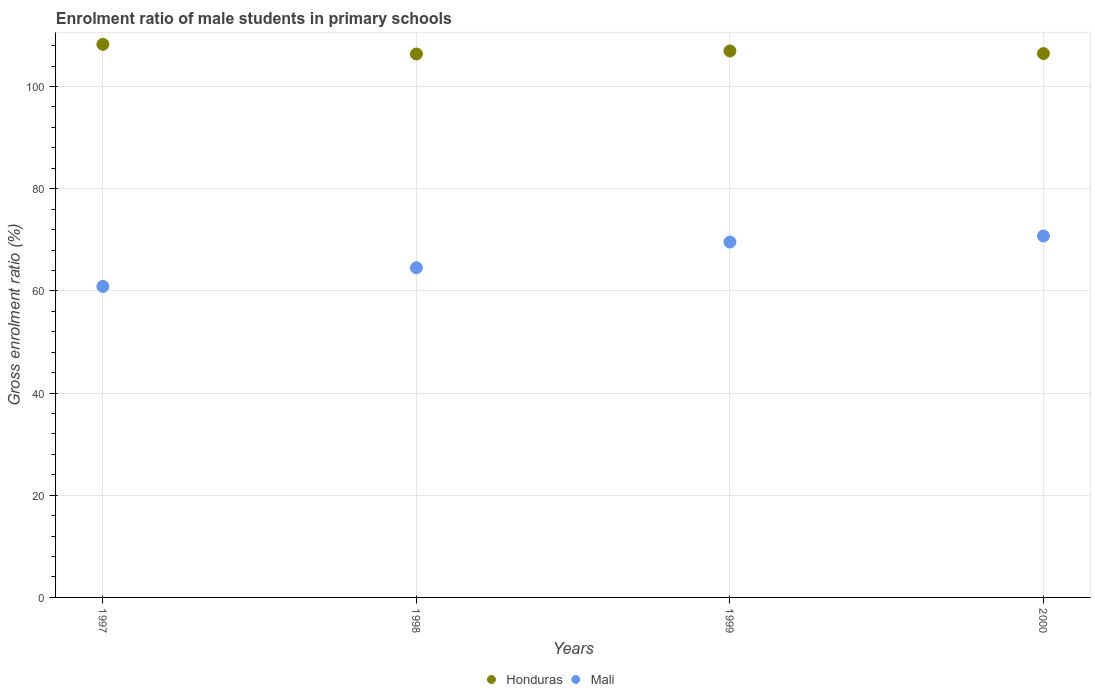Is the number of dotlines equal to the number of legend labels?
Make the answer very short. Yes. What is the enrolment ratio of male students in primary schools in Honduras in 2000?
Give a very brief answer. 106.46. Across all years, what is the maximum enrolment ratio of male students in primary schools in Mali?
Give a very brief answer. 70.75. Across all years, what is the minimum enrolment ratio of male students in primary schools in Mali?
Offer a very short reply. 60.87. In which year was the enrolment ratio of male students in primary schools in Honduras maximum?
Keep it short and to the point. 1997. What is the total enrolment ratio of male students in primary schools in Honduras in the graph?
Keep it short and to the point. 428.06. What is the difference between the enrolment ratio of male students in primary schools in Mali in 1999 and that in 2000?
Offer a terse response. -1.19. What is the difference between the enrolment ratio of male students in primary schools in Mali in 1999 and the enrolment ratio of male students in primary schools in Honduras in 2000?
Your answer should be very brief. -36.9. What is the average enrolment ratio of male students in primary schools in Mali per year?
Offer a terse response. 66.43. In the year 2000, what is the difference between the enrolment ratio of male students in primary schools in Mali and enrolment ratio of male students in primary schools in Honduras?
Your answer should be compact. -35.71. What is the ratio of the enrolment ratio of male students in primary schools in Mali in 1998 to that in 2000?
Your answer should be very brief. 0.91. Is the enrolment ratio of male students in primary schools in Mali in 1998 less than that in 2000?
Provide a short and direct response. Yes. What is the difference between the highest and the second highest enrolment ratio of male students in primary schools in Mali?
Make the answer very short. 1.19. What is the difference between the highest and the lowest enrolment ratio of male students in primary schools in Mali?
Your response must be concise. 9.88. Is the sum of the enrolment ratio of male students in primary schools in Honduras in 1997 and 2000 greater than the maximum enrolment ratio of male students in primary schools in Mali across all years?
Offer a terse response. Yes. Does the enrolment ratio of male students in primary schools in Honduras monotonically increase over the years?
Provide a short and direct response. No. How many dotlines are there?
Offer a terse response. 2. How many years are there in the graph?
Your answer should be very brief. 4. Are the values on the major ticks of Y-axis written in scientific E-notation?
Keep it short and to the point. No. Where does the legend appear in the graph?
Offer a terse response. Bottom center. How many legend labels are there?
Provide a succinct answer. 2. What is the title of the graph?
Your answer should be very brief. Enrolment ratio of male students in primary schools. What is the Gross enrolment ratio (%) of Honduras in 1997?
Offer a very short reply. 108.26. What is the Gross enrolment ratio (%) in Mali in 1997?
Offer a very short reply. 60.87. What is the Gross enrolment ratio (%) in Honduras in 1998?
Make the answer very short. 106.37. What is the Gross enrolment ratio (%) of Mali in 1998?
Your answer should be very brief. 64.52. What is the Gross enrolment ratio (%) of Honduras in 1999?
Provide a succinct answer. 106.97. What is the Gross enrolment ratio (%) of Mali in 1999?
Offer a very short reply. 69.56. What is the Gross enrolment ratio (%) in Honduras in 2000?
Offer a terse response. 106.46. What is the Gross enrolment ratio (%) in Mali in 2000?
Keep it short and to the point. 70.75. Across all years, what is the maximum Gross enrolment ratio (%) of Honduras?
Provide a succinct answer. 108.26. Across all years, what is the maximum Gross enrolment ratio (%) of Mali?
Your answer should be compact. 70.75. Across all years, what is the minimum Gross enrolment ratio (%) in Honduras?
Offer a very short reply. 106.37. Across all years, what is the minimum Gross enrolment ratio (%) of Mali?
Offer a terse response. 60.87. What is the total Gross enrolment ratio (%) in Honduras in the graph?
Make the answer very short. 428.06. What is the total Gross enrolment ratio (%) in Mali in the graph?
Offer a terse response. 265.71. What is the difference between the Gross enrolment ratio (%) in Honduras in 1997 and that in 1998?
Provide a succinct answer. 1.89. What is the difference between the Gross enrolment ratio (%) in Mali in 1997 and that in 1998?
Offer a very short reply. -3.66. What is the difference between the Gross enrolment ratio (%) in Honduras in 1997 and that in 1999?
Ensure brevity in your answer.  1.29. What is the difference between the Gross enrolment ratio (%) of Mali in 1997 and that in 1999?
Make the answer very short. -8.69. What is the difference between the Gross enrolment ratio (%) in Honduras in 1997 and that in 2000?
Offer a very short reply. 1.8. What is the difference between the Gross enrolment ratio (%) of Mali in 1997 and that in 2000?
Provide a short and direct response. -9.88. What is the difference between the Gross enrolment ratio (%) in Honduras in 1998 and that in 1999?
Your answer should be very brief. -0.59. What is the difference between the Gross enrolment ratio (%) in Mali in 1998 and that in 1999?
Your answer should be compact. -5.04. What is the difference between the Gross enrolment ratio (%) in Honduras in 1998 and that in 2000?
Give a very brief answer. -0.09. What is the difference between the Gross enrolment ratio (%) of Mali in 1998 and that in 2000?
Make the answer very short. -6.23. What is the difference between the Gross enrolment ratio (%) in Honduras in 1999 and that in 2000?
Your answer should be compact. 0.51. What is the difference between the Gross enrolment ratio (%) of Mali in 1999 and that in 2000?
Keep it short and to the point. -1.19. What is the difference between the Gross enrolment ratio (%) of Honduras in 1997 and the Gross enrolment ratio (%) of Mali in 1998?
Your answer should be compact. 43.73. What is the difference between the Gross enrolment ratio (%) of Honduras in 1997 and the Gross enrolment ratio (%) of Mali in 1999?
Keep it short and to the point. 38.7. What is the difference between the Gross enrolment ratio (%) of Honduras in 1997 and the Gross enrolment ratio (%) of Mali in 2000?
Give a very brief answer. 37.51. What is the difference between the Gross enrolment ratio (%) of Honduras in 1998 and the Gross enrolment ratio (%) of Mali in 1999?
Give a very brief answer. 36.81. What is the difference between the Gross enrolment ratio (%) of Honduras in 1998 and the Gross enrolment ratio (%) of Mali in 2000?
Give a very brief answer. 35.62. What is the difference between the Gross enrolment ratio (%) of Honduras in 1999 and the Gross enrolment ratio (%) of Mali in 2000?
Your response must be concise. 36.21. What is the average Gross enrolment ratio (%) in Honduras per year?
Provide a short and direct response. 107.01. What is the average Gross enrolment ratio (%) in Mali per year?
Your answer should be very brief. 66.43. In the year 1997, what is the difference between the Gross enrolment ratio (%) in Honduras and Gross enrolment ratio (%) in Mali?
Provide a short and direct response. 47.39. In the year 1998, what is the difference between the Gross enrolment ratio (%) in Honduras and Gross enrolment ratio (%) in Mali?
Offer a very short reply. 41.85. In the year 1999, what is the difference between the Gross enrolment ratio (%) of Honduras and Gross enrolment ratio (%) of Mali?
Offer a very short reply. 37.4. In the year 2000, what is the difference between the Gross enrolment ratio (%) of Honduras and Gross enrolment ratio (%) of Mali?
Give a very brief answer. 35.71. What is the ratio of the Gross enrolment ratio (%) of Honduras in 1997 to that in 1998?
Offer a very short reply. 1.02. What is the ratio of the Gross enrolment ratio (%) of Mali in 1997 to that in 1998?
Keep it short and to the point. 0.94. What is the ratio of the Gross enrolment ratio (%) of Honduras in 1997 to that in 1999?
Give a very brief answer. 1.01. What is the ratio of the Gross enrolment ratio (%) of Mali in 1997 to that in 1999?
Your answer should be compact. 0.88. What is the ratio of the Gross enrolment ratio (%) in Honduras in 1997 to that in 2000?
Provide a short and direct response. 1.02. What is the ratio of the Gross enrolment ratio (%) of Mali in 1997 to that in 2000?
Provide a succinct answer. 0.86. What is the ratio of the Gross enrolment ratio (%) of Honduras in 1998 to that in 1999?
Provide a short and direct response. 0.99. What is the ratio of the Gross enrolment ratio (%) in Mali in 1998 to that in 1999?
Provide a succinct answer. 0.93. What is the ratio of the Gross enrolment ratio (%) of Mali in 1998 to that in 2000?
Offer a very short reply. 0.91. What is the ratio of the Gross enrolment ratio (%) of Honduras in 1999 to that in 2000?
Your response must be concise. 1. What is the ratio of the Gross enrolment ratio (%) of Mali in 1999 to that in 2000?
Offer a very short reply. 0.98. What is the difference between the highest and the second highest Gross enrolment ratio (%) in Honduras?
Offer a terse response. 1.29. What is the difference between the highest and the second highest Gross enrolment ratio (%) in Mali?
Provide a succinct answer. 1.19. What is the difference between the highest and the lowest Gross enrolment ratio (%) of Honduras?
Offer a terse response. 1.89. What is the difference between the highest and the lowest Gross enrolment ratio (%) of Mali?
Provide a short and direct response. 9.88. 